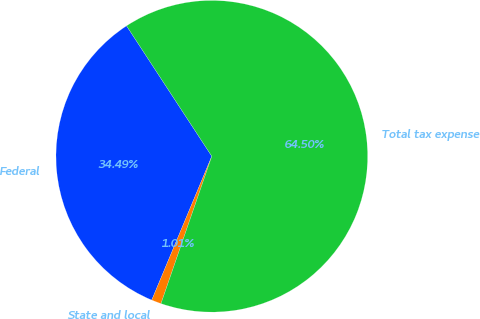Convert chart to OTSL. <chart><loc_0><loc_0><loc_500><loc_500><pie_chart><fcel>Federal<fcel>State and local<fcel>Total tax expense<nl><fcel>34.49%<fcel>1.01%<fcel>64.5%<nl></chart> 